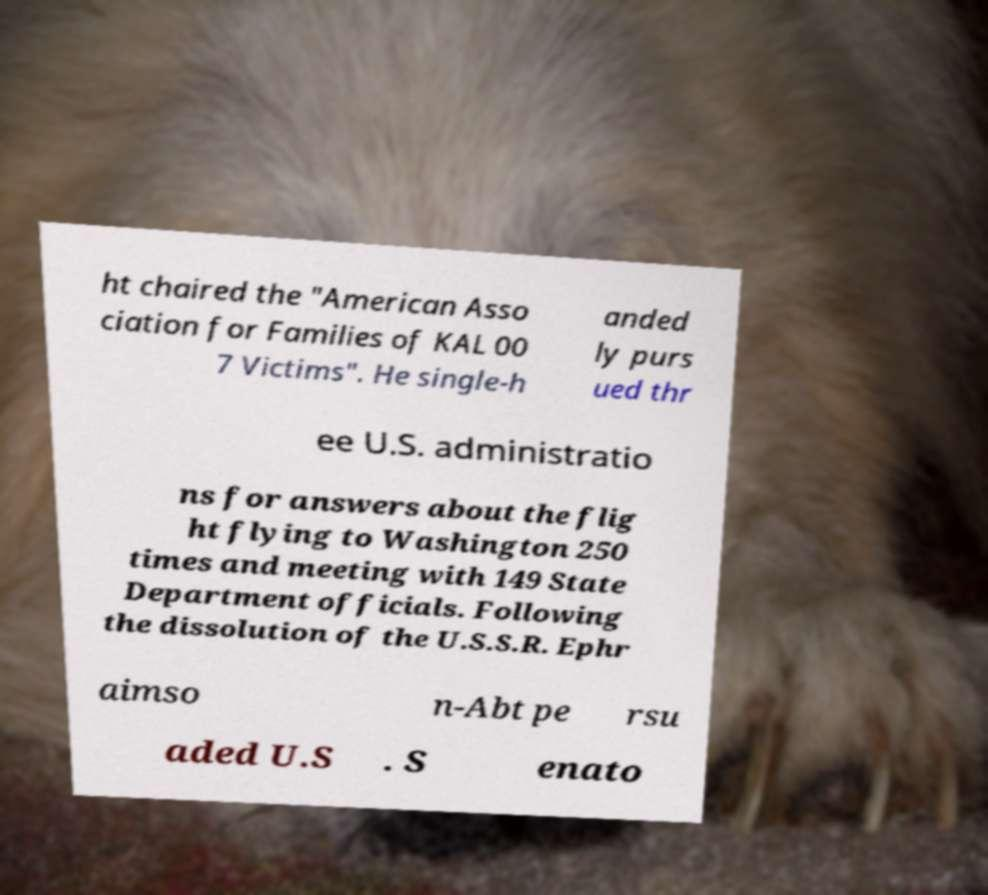Could you extract and type out the text from this image? ht chaired the "American Asso ciation for Families of KAL 00 7 Victims". He single-h anded ly purs ued thr ee U.S. administratio ns for answers about the flig ht flying to Washington 250 times and meeting with 149 State Department officials. Following the dissolution of the U.S.S.R. Ephr aimso n-Abt pe rsu aded U.S . S enato 